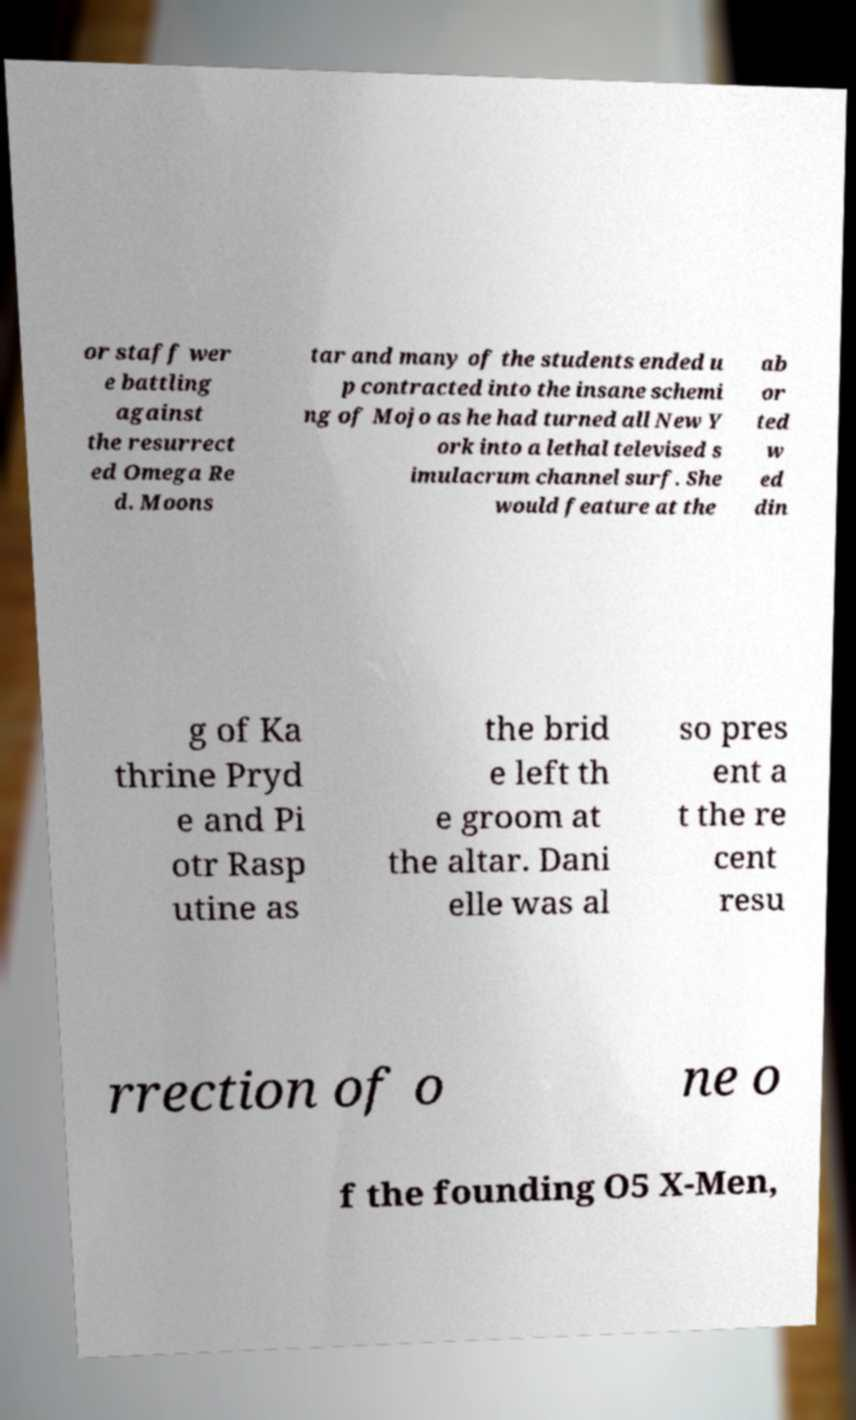What messages or text are displayed in this image? I need them in a readable, typed format. or staff wer e battling against the resurrect ed Omega Re d. Moons tar and many of the students ended u p contracted into the insane schemi ng of Mojo as he had turned all New Y ork into a lethal televised s imulacrum channel surf. She would feature at the ab or ted w ed din g of Ka thrine Pryd e and Pi otr Rasp utine as the brid e left th e groom at the altar. Dani elle was al so pres ent a t the re cent resu rrection of o ne o f the founding O5 X-Men, 